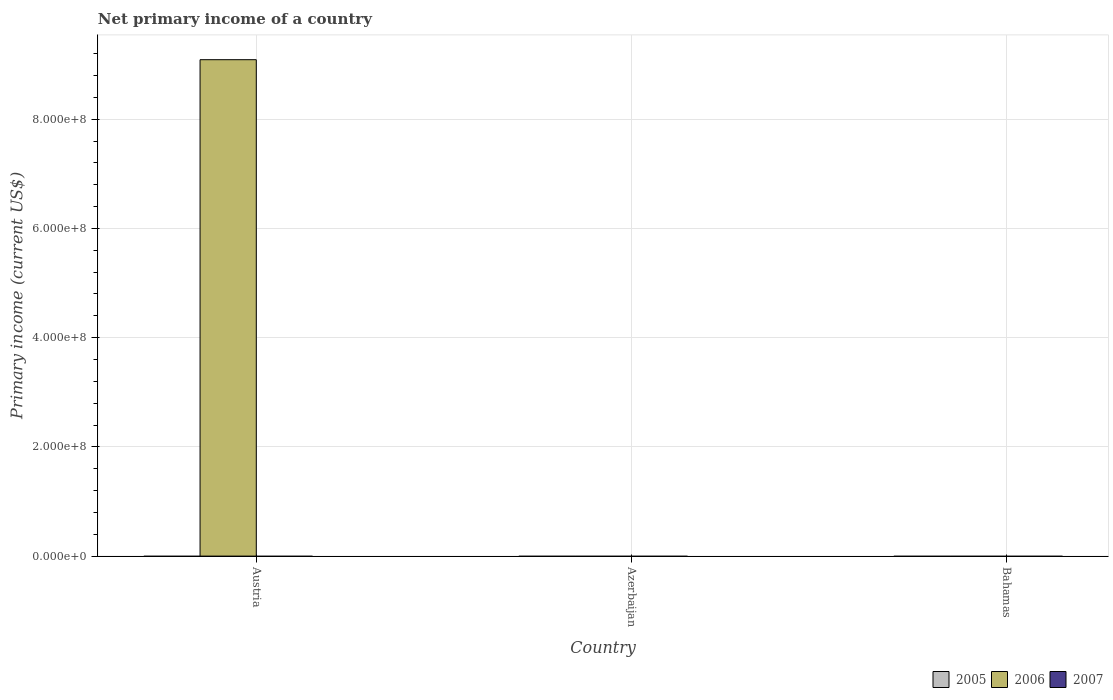Are the number of bars per tick equal to the number of legend labels?
Offer a very short reply. No. In how many cases, is the number of bars for a given country not equal to the number of legend labels?
Give a very brief answer. 3. What is the primary income in 2005 in Austria?
Provide a short and direct response. 0. Across all countries, what is the maximum primary income in 2006?
Your answer should be very brief. 9.09e+08. Across all countries, what is the minimum primary income in 2006?
Give a very brief answer. 0. In which country was the primary income in 2006 maximum?
Your answer should be compact. Austria. What is the total primary income in 2007 in the graph?
Provide a short and direct response. 0. What is the difference between the primary income in 2007 in Austria and the primary income in 2006 in Bahamas?
Keep it short and to the point. 0. What is the average primary income in 2006 per country?
Your answer should be compact. 3.03e+08. What is the difference between the highest and the lowest primary income in 2006?
Provide a short and direct response. 9.09e+08. In how many countries, is the primary income in 2007 greater than the average primary income in 2007 taken over all countries?
Provide a succinct answer. 0. How many countries are there in the graph?
Your answer should be compact. 3. What is the difference between two consecutive major ticks on the Y-axis?
Your answer should be compact. 2.00e+08. Does the graph contain grids?
Keep it short and to the point. Yes. Where does the legend appear in the graph?
Your answer should be very brief. Bottom right. How are the legend labels stacked?
Provide a short and direct response. Horizontal. What is the title of the graph?
Offer a terse response. Net primary income of a country. Does "2000" appear as one of the legend labels in the graph?
Provide a short and direct response. No. What is the label or title of the X-axis?
Provide a short and direct response. Country. What is the label or title of the Y-axis?
Offer a very short reply. Primary income (current US$). What is the Primary income (current US$) of 2005 in Austria?
Your answer should be very brief. 0. What is the Primary income (current US$) of 2006 in Austria?
Offer a terse response. 9.09e+08. What is the Primary income (current US$) in 2006 in Azerbaijan?
Make the answer very short. 0. What is the Primary income (current US$) in 2005 in Bahamas?
Provide a short and direct response. 0. What is the Primary income (current US$) of 2007 in Bahamas?
Offer a terse response. 0. Across all countries, what is the maximum Primary income (current US$) in 2006?
Your answer should be very brief. 9.09e+08. What is the total Primary income (current US$) in 2005 in the graph?
Your response must be concise. 0. What is the total Primary income (current US$) of 2006 in the graph?
Make the answer very short. 9.09e+08. What is the average Primary income (current US$) in 2005 per country?
Your answer should be very brief. 0. What is the average Primary income (current US$) of 2006 per country?
Offer a terse response. 3.03e+08. What is the difference between the highest and the lowest Primary income (current US$) in 2006?
Ensure brevity in your answer.  9.09e+08. 